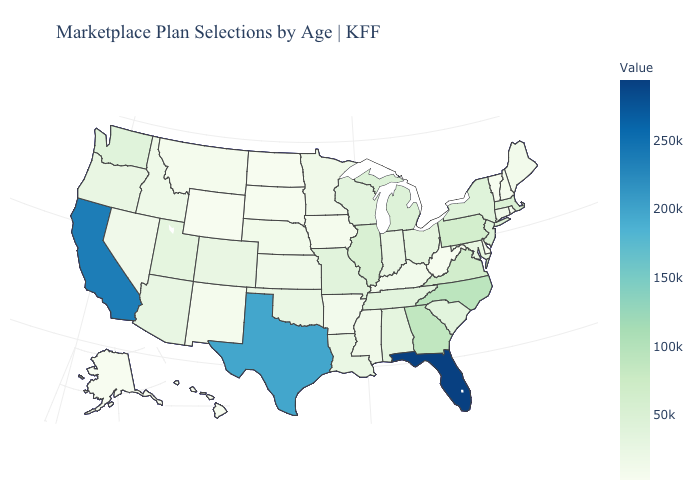Does Arkansas have the highest value in the USA?
Write a very short answer. No. Is the legend a continuous bar?
Keep it brief. Yes. Does Colorado have a higher value than Florida?
Short answer required. No. Which states have the lowest value in the USA?
Write a very short answer. North Dakota. Which states hav the highest value in the West?
Give a very brief answer. California. 